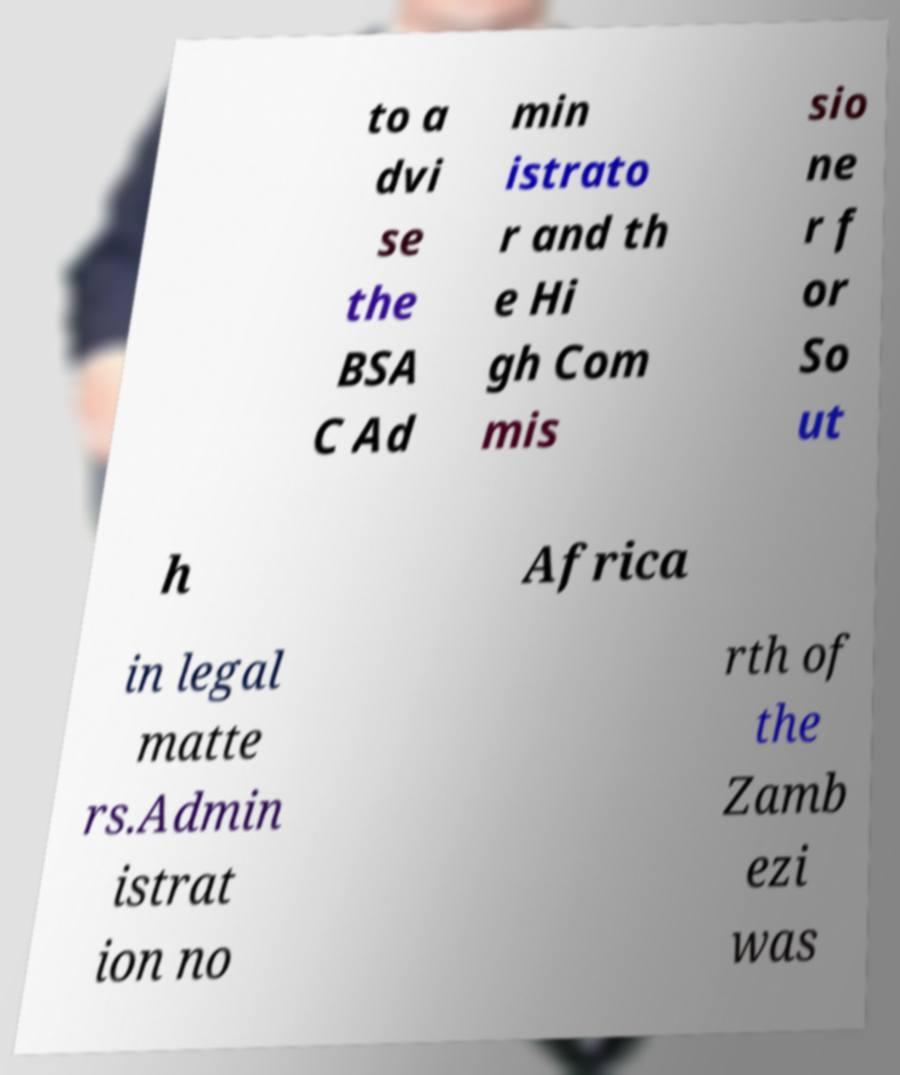Can you accurately transcribe the text from the provided image for me? to a dvi se the BSA C Ad min istrato r and th e Hi gh Com mis sio ne r f or So ut h Africa in legal matte rs.Admin istrat ion no rth of the Zamb ezi was 